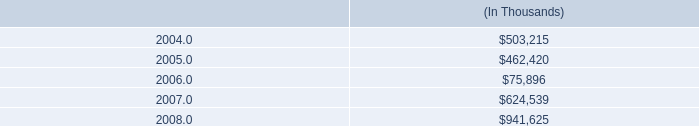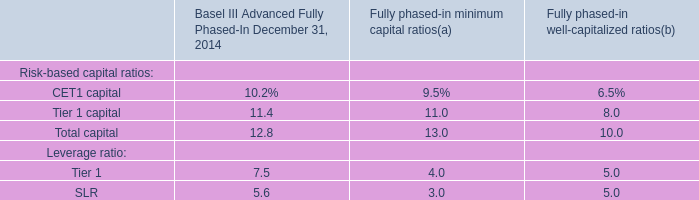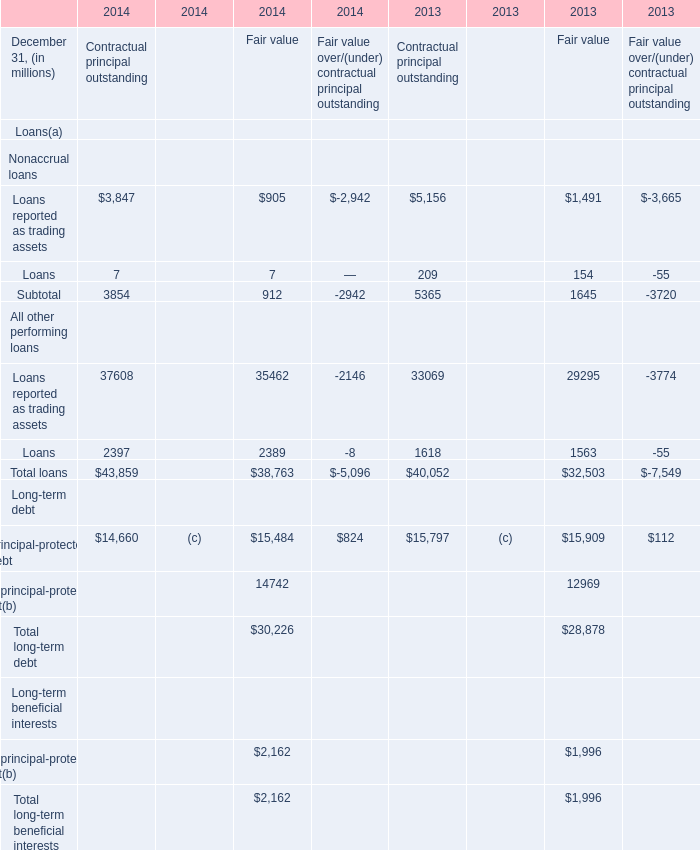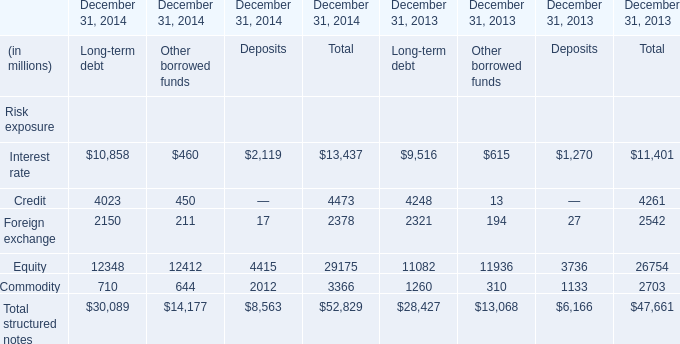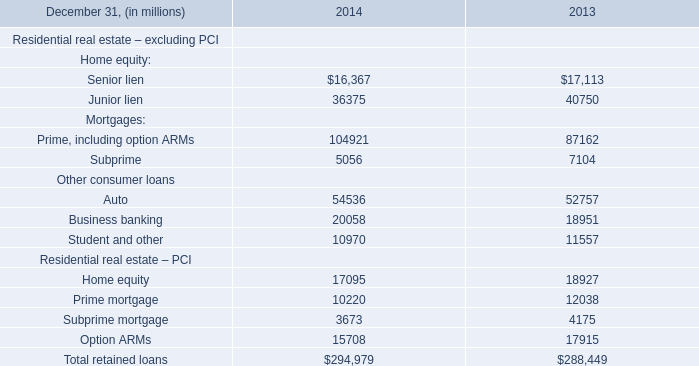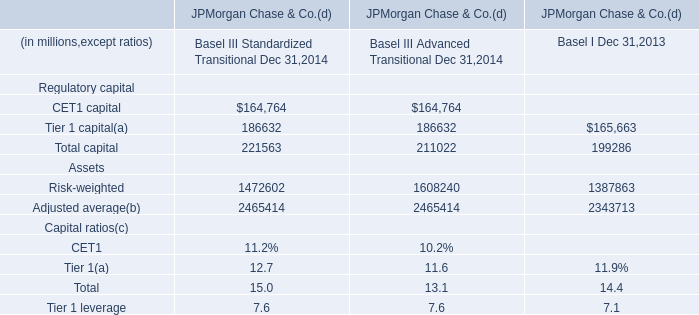What's the total value of all Deposits that are smaller than 3000 in 2014? (in million) 
Computations: ((2119 + 2012) + 17)
Answer: 4148.0. 